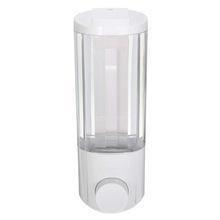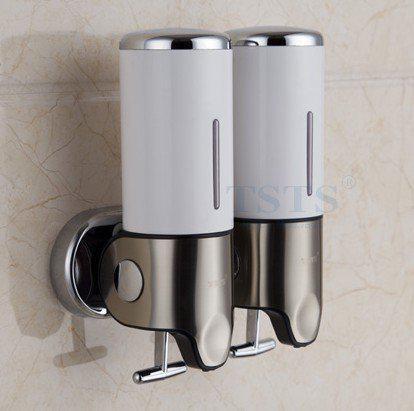The first image is the image on the left, the second image is the image on the right. Evaluate the accuracy of this statement regarding the images: "Five bathroom dispensers are divided into groups of two and three, each grouping having at least one liquid color in common with the other.". Is it true? Answer yes or no. No. The first image is the image on the left, the second image is the image on the right. Examine the images to the left and right. Is the description "There are three dispensers in the image on the right." accurate? Answer yes or no. No. 